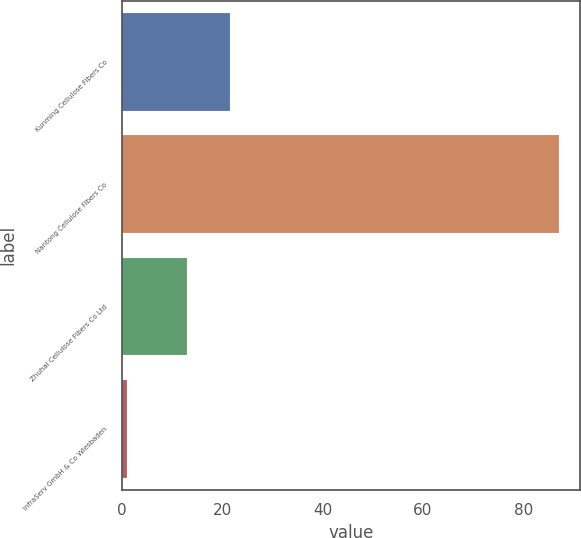Convert chart to OTSL. <chart><loc_0><loc_0><loc_500><loc_500><bar_chart><fcel>Kunming Cellulose Fibers Co<fcel>Nantong Cellulose Fibers Co<fcel>Zhuhai Cellulose Fibers Co Ltd<fcel>InfraServ GmbH & Co Wiesbaden<nl><fcel>21.6<fcel>87<fcel>13<fcel>1<nl></chart> 